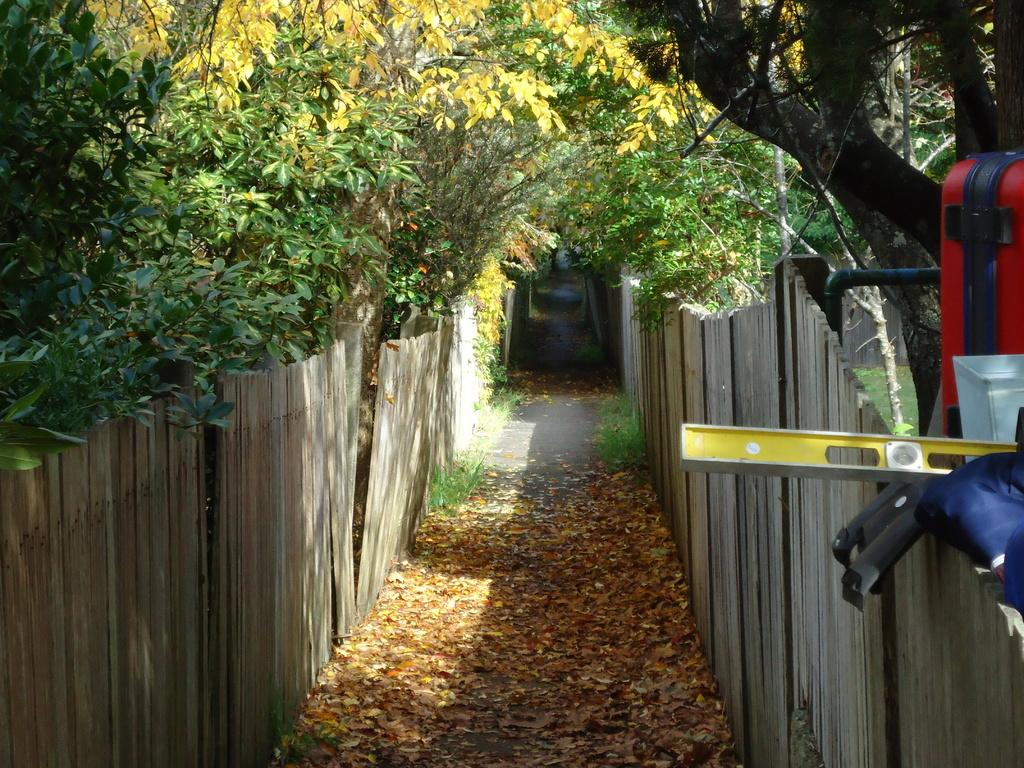What type of surface can be seen at the bottom of the image? The ground is visible in the image. What kind of barrier is present in the image? There is a wooden fence in the image. What type of vegetation is present in the image? There are trees and grass in the image. What additional feature can be seen on the ground? Dried leaves are present in the image. What objects are located on the right side of the image? There are objects on the right side of the image. What type of quilt is draped over the tree in the image? There is no quilt present in the image; it features a wooden fence, trees, grass, and dried leaves. How much does the sun weigh in the image? The image does not depict the sun, so its weight cannot be determined. 